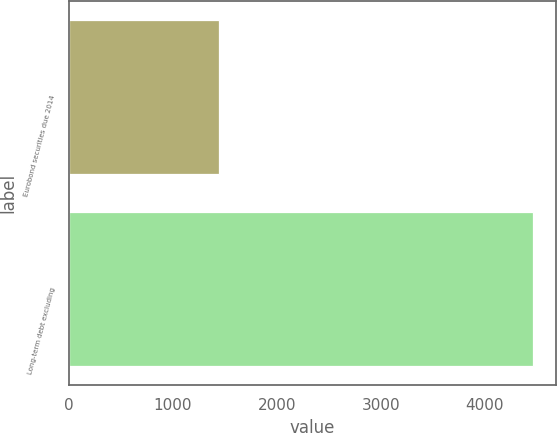<chart> <loc_0><loc_0><loc_500><loc_500><bar_chart><fcel>Eurobond securities due 2014<fcel>Long-term debt excluding<nl><fcel>1447<fcel>4463<nl></chart> 